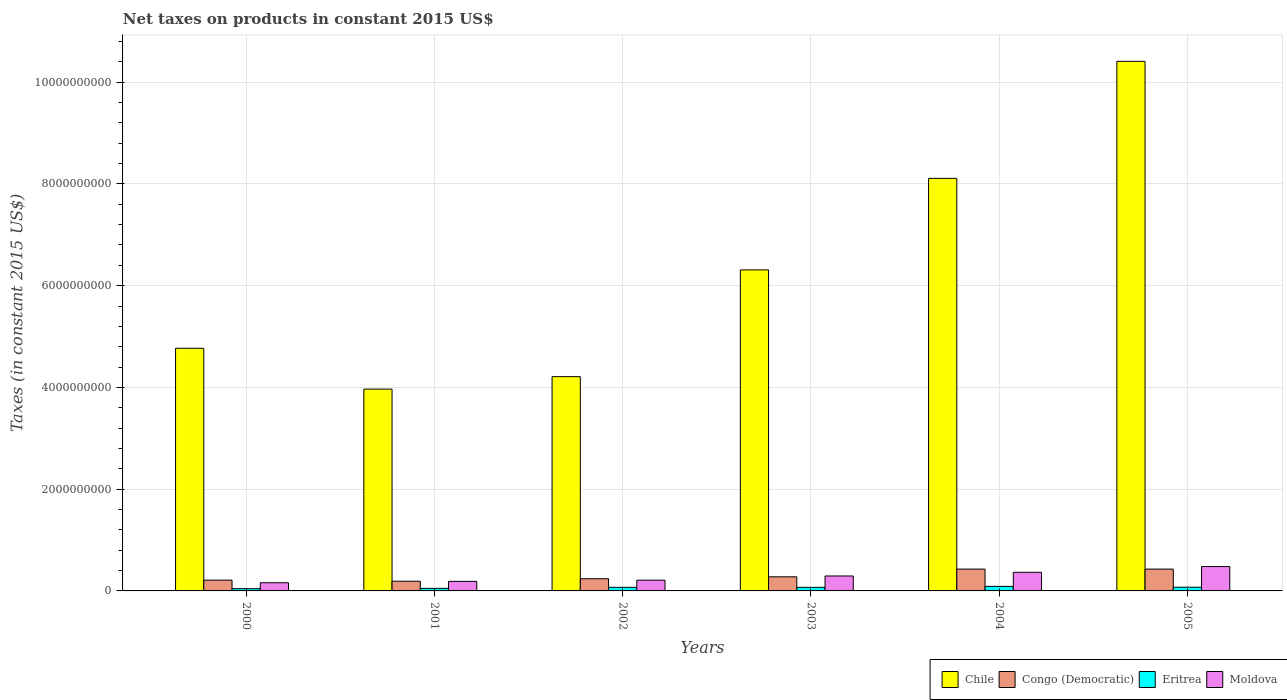How many different coloured bars are there?
Provide a succinct answer. 4. Are the number of bars per tick equal to the number of legend labels?
Offer a very short reply. Yes. Are the number of bars on each tick of the X-axis equal?
Ensure brevity in your answer.  Yes. What is the label of the 5th group of bars from the left?
Offer a very short reply. 2004. What is the net taxes on products in Chile in 2002?
Your response must be concise. 4.21e+09. Across all years, what is the maximum net taxes on products in Chile?
Offer a terse response. 1.04e+1. Across all years, what is the minimum net taxes on products in Chile?
Provide a succinct answer. 3.97e+09. In which year was the net taxes on products in Chile minimum?
Your answer should be very brief. 2001. What is the total net taxes on products in Eritrea in the graph?
Your response must be concise. 3.98e+08. What is the difference between the net taxes on products in Congo (Democratic) in 2003 and that in 2005?
Keep it short and to the point. -1.52e+08. What is the difference between the net taxes on products in Chile in 2000 and the net taxes on products in Congo (Democratic) in 2001?
Ensure brevity in your answer.  4.58e+09. What is the average net taxes on products in Chile per year?
Offer a very short reply. 6.30e+09. In the year 2004, what is the difference between the net taxes on products in Chile and net taxes on products in Congo (Democratic)?
Give a very brief answer. 7.68e+09. In how many years, is the net taxes on products in Moldova greater than 6400000000 US$?
Your answer should be compact. 0. What is the ratio of the net taxes on products in Chile in 2000 to that in 2001?
Offer a very short reply. 1.2. Is the net taxes on products in Congo (Democratic) in 2003 less than that in 2005?
Provide a short and direct response. Yes. Is the difference between the net taxes on products in Chile in 2003 and 2005 greater than the difference between the net taxes on products in Congo (Democratic) in 2003 and 2005?
Make the answer very short. No. What is the difference between the highest and the second highest net taxes on products in Chile?
Provide a succinct answer. 2.30e+09. What is the difference between the highest and the lowest net taxes on products in Moldova?
Provide a succinct answer. 3.18e+08. What does the 4th bar from the left in 2002 represents?
Your answer should be compact. Moldova. What does the 3rd bar from the right in 2003 represents?
Ensure brevity in your answer.  Congo (Democratic). Are all the bars in the graph horizontal?
Offer a terse response. No. How many years are there in the graph?
Your response must be concise. 6. What is the difference between two consecutive major ticks on the Y-axis?
Offer a very short reply. 2.00e+09. How many legend labels are there?
Your answer should be very brief. 4. What is the title of the graph?
Keep it short and to the point. Net taxes on products in constant 2015 US$. What is the label or title of the X-axis?
Offer a terse response. Years. What is the label or title of the Y-axis?
Provide a short and direct response. Taxes (in constant 2015 US$). What is the Taxes (in constant 2015 US$) in Chile in 2000?
Make the answer very short. 4.77e+09. What is the Taxes (in constant 2015 US$) in Congo (Democratic) in 2000?
Make the answer very short. 2.12e+08. What is the Taxes (in constant 2015 US$) in Eritrea in 2000?
Provide a short and direct response. 4.44e+07. What is the Taxes (in constant 2015 US$) in Moldova in 2000?
Provide a succinct answer. 1.61e+08. What is the Taxes (in constant 2015 US$) in Chile in 2001?
Your answer should be compact. 3.97e+09. What is the Taxes (in constant 2015 US$) in Congo (Democratic) in 2001?
Keep it short and to the point. 1.91e+08. What is the Taxes (in constant 2015 US$) of Eritrea in 2001?
Ensure brevity in your answer.  5.02e+07. What is the Taxes (in constant 2015 US$) of Moldova in 2001?
Provide a short and direct response. 1.88e+08. What is the Taxes (in constant 2015 US$) of Chile in 2002?
Offer a terse response. 4.21e+09. What is the Taxes (in constant 2015 US$) of Congo (Democratic) in 2002?
Ensure brevity in your answer.  2.40e+08. What is the Taxes (in constant 2015 US$) of Eritrea in 2002?
Provide a short and direct response. 7.06e+07. What is the Taxes (in constant 2015 US$) of Moldova in 2002?
Your answer should be very brief. 2.11e+08. What is the Taxes (in constant 2015 US$) in Chile in 2003?
Your response must be concise. 6.31e+09. What is the Taxes (in constant 2015 US$) in Congo (Democratic) in 2003?
Offer a terse response. 2.77e+08. What is the Taxes (in constant 2015 US$) in Eritrea in 2003?
Provide a short and direct response. 7.06e+07. What is the Taxes (in constant 2015 US$) of Moldova in 2003?
Make the answer very short. 2.94e+08. What is the Taxes (in constant 2015 US$) of Chile in 2004?
Your answer should be compact. 8.11e+09. What is the Taxes (in constant 2015 US$) of Congo (Democratic) in 2004?
Keep it short and to the point. 4.29e+08. What is the Taxes (in constant 2015 US$) of Eritrea in 2004?
Provide a short and direct response. 8.94e+07. What is the Taxes (in constant 2015 US$) in Moldova in 2004?
Provide a short and direct response. 3.66e+08. What is the Taxes (in constant 2015 US$) of Chile in 2005?
Give a very brief answer. 1.04e+1. What is the Taxes (in constant 2015 US$) of Congo (Democratic) in 2005?
Your response must be concise. 4.29e+08. What is the Taxes (in constant 2015 US$) in Eritrea in 2005?
Your answer should be compact. 7.30e+07. What is the Taxes (in constant 2015 US$) in Moldova in 2005?
Your answer should be compact. 4.79e+08. Across all years, what is the maximum Taxes (in constant 2015 US$) in Chile?
Keep it short and to the point. 1.04e+1. Across all years, what is the maximum Taxes (in constant 2015 US$) of Congo (Democratic)?
Your answer should be very brief. 4.29e+08. Across all years, what is the maximum Taxes (in constant 2015 US$) in Eritrea?
Provide a succinct answer. 8.94e+07. Across all years, what is the maximum Taxes (in constant 2015 US$) in Moldova?
Make the answer very short. 4.79e+08. Across all years, what is the minimum Taxes (in constant 2015 US$) of Chile?
Provide a short and direct response. 3.97e+09. Across all years, what is the minimum Taxes (in constant 2015 US$) of Congo (Democratic)?
Offer a very short reply. 1.91e+08. Across all years, what is the minimum Taxes (in constant 2015 US$) in Eritrea?
Ensure brevity in your answer.  4.44e+07. Across all years, what is the minimum Taxes (in constant 2015 US$) in Moldova?
Offer a terse response. 1.61e+08. What is the total Taxes (in constant 2015 US$) in Chile in the graph?
Offer a terse response. 3.78e+1. What is the total Taxes (in constant 2015 US$) in Congo (Democratic) in the graph?
Offer a very short reply. 1.78e+09. What is the total Taxes (in constant 2015 US$) of Eritrea in the graph?
Keep it short and to the point. 3.98e+08. What is the total Taxes (in constant 2015 US$) in Moldova in the graph?
Offer a terse response. 1.70e+09. What is the difference between the Taxes (in constant 2015 US$) of Chile in 2000 and that in 2001?
Make the answer very short. 8.04e+08. What is the difference between the Taxes (in constant 2015 US$) of Congo (Democratic) in 2000 and that in 2001?
Provide a short and direct response. 2.06e+07. What is the difference between the Taxes (in constant 2015 US$) of Eritrea in 2000 and that in 2001?
Your answer should be compact. -5.80e+06. What is the difference between the Taxes (in constant 2015 US$) of Moldova in 2000 and that in 2001?
Give a very brief answer. -2.71e+07. What is the difference between the Taxes (in constant 2015 US$) of Chile in 2000 and that in 2002?
Your response must be concise. 5.58e+08. What is the difference between the Taxes (in constant 2015 US$) in Congo (Democratic) in 2000 and that in 2002?
Make the answer very short. -2.81e+07. What is the difference between the Taxes (in constant 2015 US$) of Eritrea in 2000 and that in 2002?
Your answer should be compact. -2.62e+07. What is the difference between the Taxes (in constant 2015 US$) in Moldova in 2000 and that in 2002?
Your answer should be compact. -5.05e+07. What is the difference between the Taxes (in constant 2015 US$) in Chile in 2000 and that in 2003?
Make the answer very short. -1.54e+09. What is the difference between the Taxes (in constant 2015 US$) in Congo (Democratic) in 2000 and that in 2003?
Your answer should be compact. -6.54e+07. What is the difference between the Taxes (in constant 2015 US$) in Eritrea in 2000 and that in 2003?
Offer a terse response. -2.62e+07. What is the difference between the Taxes (in constant 2015 US$) of Moldova in 2000 and that in 2003?
Provide a short and direct response. -1.33e+08. What is the difference between the Taxes (in constant 2015 US$) of Chile in 2000 and that in 2004?
Provide a succinct answer. -3.34e+09. What is the difference between the Taxes (in constant 2015 US$) of Congo (Democratic) in 2000 and that in 2004?
Your response must be concise. -2.17e+08. What is the difference between the Taxes (in constant 2015 US$) in Eritrea in 2000 and that in 2004?
Give a very brief answer. -4.50e+07. What is the difference between the Taxes (in constant 2015 US$) of Moldova in 2000 and that in 2004?
Give a very brief answer. -2.06e+08. What is the difference between the Taxes (in constant 2015 US$) of Chile in 2000 and that in 2005?
Offer a terse response. -5.64e+09. What is the difference between the Taxes (in constant 2015 US$) of Congo (Democratic) in 2000 and that in 2005?
Provide a succinct answer. -2.17e+08. What is the difference between the Taxes (in constant 2015 US$) of Eritrea in 2000 and that in 2005?
Ensure brevity in your answer.  -2.86e+07. What is the difference between the Taxes (in constant 2015 US$) in Moldova in 2000 and that in 2005?
Provide a short and direct response. -3.18e+08. What is the difference between the Taxes (in constant 2015 US$) of Chile in 2001 and that in 2002?
Offer a terse response. -2.45e+08. What is the difference between the Taxes (in constant 2015 US$) of Congo (Democratic) in 2001 and that in 2002?
Provide a short and direct response. -4.87e+07. What is the difference between the Taxes (in constant 2015 US$) in Eritrea in 2001 and that in 2002?
Give a very brief answer. -2.04e+07. What is the difference between the Taxes (in constant 2015 US$) in Moldova in 2001 and that in 2002?
Offer a terse response. -2.35e+07. What is the difference between the Taxes (in constant 2015 US$) of Chile in 2001 and that in 2003?
Your answer should be very brief. -2.34e+09. What is the difference between the Taxes (in constant 2015 US$) of Congo (Democratic) in 2001 and that in 2003?
Offer a very short reply. -8.60e+07. What is the difference between the Taxes (in constant 2015 US$) in Eritrea in 2001 and that in 2003?
Offer a terse response. -2.04e+07. What is the difference between the Taxes (in constant 2015 US$) in Moldova in 2001 and that in 2003?
Your response must be concise. -1.06e+08. What is the difference between the Taxes (in constant 2015 US$) in Chile in 2001 and that in 2004?
Your answer should be compact. -4.14e+09. What is the difference between the Taxes (in constant 2015 US$) in Congo (Democratic) in 2001 and that in 2004?
Your response must be concise. -2.38e+08. What is the difference between the Taxes (in constant 2015 US$) of Eritrea in 2001 and that in 2004?
Offer a terse response. -3.92e+07. What is the difference between the Taxes (in constant 2015 US$) of Moldova in 2001 and that in 2004?
Provide a succinct answer. -1.78e+08. What is the difference between the Taxes (in constant 2015 US$) of Chile in 2001 and that in 2005?
Offer a very short reply. -6.44e+09. What is the difference between the Taxes (in constant 2015 US$) in Congo (Democratic) in 2001 and that in 2005?
Give a very brief answer. -2.38e+08. What is the difference between the Taxes (in constant 2015 US$) of Eritrea in 2001 and that in 2005?
Offer a terse response. -2.28e+07. What is the difference between the Taxes (in constant 2015 US$) in Moldova in 2001 and that in 2005?
Provide a short and direct response. -2.91e+08. What is the difference between the Taxes (in constant 2015 US$) of Chile in 2002 and that in 2003?
Offer a terse response. -2.10e+09. What is the difference between the Taxes (in constant 2015 US$) in Congo (Democratic) in 2002 and that in 2003?
Offer a very short reply. -3.73e+07. What is the difference between the Taxes (in constant 2015 US$) in Eritrea in 2002 and that in 2003?
Offer a very short reply. -1.22e+04. What is the difference between the Taxes (in constant 2015 US$) of Moldova in 2002 and that in 2003?
Make the answer very short. -8.26e+07. What is the difference between the Taxes (in constant 2015 US$) in Chile in 2002 and that in 2004?
Provide a short and direct response. -3.90e+09. What is the difference between the Taxes (in constant 2015 US$) of Congo (Democratic) in 2002 and that in 2004?
Provide a short and direct response. -1.89e+08. What is the difference between the Taxes (in constant 2015 US$) in Eritrea in 2002 and that in 2004?
Ensure brevity in your answer.  -1.88e+07. What is the difference between the Taxes (in constant 2015 US$) in Moldova in 2002 and that in 2004?
Make the answer very short. -1.55e+08. What is the difference between the Taxes (in constant 2015 US$) of Chile in 2002 and that in 2005?
Your answer should be compact. -6.20e+09. What is the difference between the Taxes (in constant 2015 US$) in Congo (Democratic) in 2002 and that in 2005?
Provide a short and direct response. -1.89e+08. What is the difference between the Taxes (in constant 2015 US$) of Eritrea in 2002 and that in 2005?
Your response must be concise. -2.41e+06. What is the difference between the Taxes (in constant 2015 US$) in Moldova in 2002 and that in 2005?
Your answer should be compact. -2.68e+08. What is the difference between the Taxes (in constant 2015 US$) of Chile in 2003 and that in 2004?
Keep it short and to the point. -1.80e+09. What is the difference between the Taxes (in constant 2015 US$) of Congo (Democratic) in 2003 and that in 2004?
Your answer should be compact. -1.52e+08. What is the difference between the Taxes (in constant 2015 US$) of Eritrea in 2003 and that in 2004?
Give a very brief answer. -1.88e+07. What is the difference between the Taxes (in constant 2015 US$) in Moldova in 2003 and that in 2004?
Ensure brevity in your answer.  -7.24e+07. What is the difference between the Taxes (in constant 2015 US$) in Chile in 2003 and that in 2005?
Give a very brief answer. -4.10e+09. What is the difference between the Taxes (in constant 2015 US$) in Congo (Democratic) in 2003 and that in 2005?
Keep it short and to the point. -1.52e+08. What is the difference between the Taxes (in constant 2015 US$) in Eritrea in 2003 and that in 2005?
Provide a succinct answer. -2.40e+06. What is the difference between the Taxes (in constant 2015 US$) of Moldova in 2003 and that in 2005?
Keep it short and to the point. -1.85e+08. What is the difference between the Taxes (in constant 2015 US$) in Chile in 2004 and that in 2005?
Give a very brief answer. -2.30e+09. What is the difference between the Taxes (in constant 2015 US$) in Congo (Democratic) in 2004 and that in 2005?
Your answer should be compact. 3.69e+04. What is the difference between the Taxes (in constant 2015 US$) in Eritrea in 2004 and that in 2005?
Keep it short and to the point. 1.64e+07. What is the difference between the Taxes (in constant 2015 US$) in Moldova in 2004 and that in 2005?
Provide a succinct answer. -1.13e+08. What is the difference between the Taxes (in constant 2015 US$) of Chile in 2000 and the Taxes (in constant 2015 US$) of Congo (Democratic) in 2001?
Your answer should be compact. 4.58e+09. What is the difference between the Taxes (in constant 2015 US$) of Chile in 2000 and the Taxes (in constant 2015 US$) of Eritrea in 2001?
Provide a succinct answer. 4.72e+09. What is the difference between the Taxes (in constant 2015 US$) in Chile in 2000 and the Taxes (in constant 2015 US$) in Moldova in 2001?
Ensure brevity in your answer.  4.58e+09. What is the difference between the Taxes (in constant 2015 US$) in Congo (Democratic) in 2000 and the Taxes (in constant 2015 US$) in Eritrea in 2001?
Give a very brief answer. 1.61e+08. What is the difference between the Taxes (in constant 2015 US$) of Congo (Democratic) in 2000 and the Taxes (in constant 2015 US$) of Moldova in 2001?
Make the answer very short. 2.39e+07. What is the difference between the Taxes (in constant 2015 US$) in Eritrea in 2000 and the Taxes (in constant 2015 US$) in Moldova in 2001?
Provide a succinct answer. -1.43e+08. What is the difference between the Taxes (in constant 2015 US$) of Chile in 2000 and the Taxes (in constant 2015 US$) of Congo (Democratic) in 2002?
Keep it short and to the point. 4.53e+09. What is the difference between the Taxes (in constant 2015 US$) of Chile in 2000 and the Taxes (in constant 2015 US$) of Eritrea in 2002?
Your answer should be compact. 4.70e+09. What is the difference between the Taxes (in constant 2015 US$) of Chile in 2000 and the Taxes (in constant 2015 US$) of Moldova in 2002?
Make the answer very short. 4.56e+09. What is the difference between the Taxes (in constant 2015 US$) of Congo (Democratic) in 2000 and the Taxes (in constant 2015 US$) of Eritrea in 2002?
Give a very brief answer. 1.41e+08. What is the difference between the Taxes (in constant 2015 US$) of Congo (Democratic) in 2000 and the Taxes (in constant 2015 US$) of Moldova in 2002?
Your answer should be very brief. 3.98e+05. What is the difference between the Taxes (in constant 2015 US$) of Eritrea in 2000 and the Taxes (in constant 2015 US$) of Moldova in 2002?
Your answer should be compact. -1.67e+08. What is the difference between the Taxes (in constant 2015 US$) of Chile in 2000 and the Taxes (in constant 2015 US$) of Congo (Democratic) in 2003?
Your answer should be very brief. 4.49e+09. What is the difference between the Taxes (in constant 2015 US$) of Chile in 2000 and the Taxes (in constant 2015 US$) of Eritrea in 2003?
Provide a succinct answer. 4.70e+09. What is the difference between the Taxes (in constant 2015 US$) in Chile in 2000 and the Taxes (in constant 2015 US$) in Moldova in 2003?
Offer a very short reply. 4.48e+09. What is the difference between the Taxes (in constant 2015 US$) in Congo (Democratic) in 2000 and the Taxes (in constant 2015 US$) in Eritrea in 2003?
Offer a very short reply. 1.41e+08. What is the difference between the Taxes (in constant 2015 US$) in Congo (Democratic) in 2000 and the Taxes (in constant 2015 US$) in Moldova in 2003?
Your answer should be very brief. -8.22e+07. What is the difference between the Taxes (in constant 2015 US$) in Eritrea in 2000 and the Taxes (in constant 2015 US$) in Moldova in 2003?
Provide a short and direct response. -2.49e+08. What is the difference between the Taxes (in constant 2015 US$) of Chile in 2000 and the Taxes (in constant 2015 US$) of Congo (Democratic) in 2004?
Make the answer very short. 4.34e+09. What is the difference between the Taxes (in constant 2015 US$) in Chile in 2000 and the Taxes (in constant 2015 US$) in Eritrea in 2004?
Offer a very short reply. 4.68e+09. What is the difference between the Taxes (in constant 2015 US$) of Chile in 2000 and the Taxes (in constant 2015 US$) of Moldova in 2004?
Provide a short and direct response. 4.40e+09. What is the difference between the Taxes (in constant 2015 US$) in Congo (Democratic) in 2000 and the Taxes (in constant 2015 US$) in Eritrea in 2004?
Provide a succinct answer. 1.22e+08. What is the difference between the Taxes (in constant 2015 US$) of Congo (Democratic) in 2000 and the Taxes (in constant 2015 US$) of Moldova in 2004?
Your answer should be very brief. -1.55e+08. What is the difference between the Taxes (in constant 2015 US$) of Eritrea in 2000 and the Taxes (in constant 2015 US$) of Moldova in 2004?
Provide a short and direct response. -3.22e+08. What is the difference between the Taxes (in constant 2015 US$) of Chile in 2000 and the Taxes (in constant 2015 US$) of Congo (Democratic) in 2005?
Your answer should be very brief. 4.34e+09. What is the difference between the Taxes (in constant 2015 US$) in Chile in 2000 and the Taxes (in constant 2015 US$) in Eritrea in 2005?
Your answer should be very brief. 4.70e+09. What is the difference between the Taxes (in constant 2015 US$) in Chile in 2000 and the Taxes (in constant 2015 US$) in Moldova in 2005?
Your answer should be compact. 4.29e+09. What is the difference between the Taxes (in constant 2015 US$) of Congo (Democratic) in 2000 and the Taxes (in constant 2015 US$) of Eritrea in 2005?
Your answer should be very brief. 1.39e+08. What is the difference between the Taxes (in constant 2015 US$) of Congo (Democratic) in 2000 and the Taxes (in constant 2015 US$) of Moldova in 2005?
Your answer should be compact. -2.67e+08. What is the difference between the Taxes (in constant 2015 US$) in Eritrea in 2000 and the Taxes (in constant 2015 US$) in Moldova in 2005?
Give a very brief answer. -4.35e+08. What is the difference between the Taxes (in constant 2015 US$) of Chile in 2001 and the Taxes (in constant 2015 US$) of Congo (Democratic) in 2002?
Offer a terse response. 3.73e+09. What is the difference between the Taxes (in constant 2015 US$) of Chile in 2001 and the Taxes (in constant 2015 US$) of Eritrea in 2002?
Provide a succinct answer. 3.90e+09. What is the difference between the Taxes (in constant 2015 US$) of Chile in 2001 and the Taxes (in constant 2015 US$) of Moldova in 2002?
Offer a terse response. 3.75e+09. What is the difference between the Taxes (in constant 2015 US$) in Congo (Democratic) in 2001 and the Taxes (in constant 2015 US$) in Eritrea in 2002?
Provide a short and direct response. 1.20e+08. What is the difference between the Taxes (in constant 2015 US$) of Congo (Democratic) in 2001 and the Taxes (in constant 2015 US$) of Moldova in 2002?
Provide a succinct answer. -2.02e+07. What is the difference between the Taxes (in constant 2015 US$) in Eritrea in 2001 and the Taxes (in constant 2015 US$) in Moldova in 2002?
Your answer should be very brief. -1.61e+08. What is the difference between the Taxes (in constant 2015 US$) of Chile in 2001 and the Taxes (in constant 2015 US$) of Congo (Democratic) in 2003?
Your response must be concise. 3.69e+09. What is the difference between the Taxes (in constant 2015 US$) of Chile in 2001 and the Taxes (in constant 2015 US$) of Eritrea in 2003?
Offer a terse response. 3.90e+09. What is the difference between the Taxes (in constant 2015 US$) of Chile in 2001 and the Taxes (in constant 2015 US$) of Moldova in 2003?
Offer a very short reply. 3.67e+09. What is the difference between the Taxes (in constant 2015 US$) in Congo (Democratic) in 2001 and the Taxes (in constant 2015 US$) in Eritrea in 2003?
Offer a very short reply. 1.20e+08. What is the difference between the Taxes (in constant 2015 US$) of Congo (Democratic) in 2001 and the Taxes (in constant 2015 US$) of Moldova in 2003?
Keep it short and to the point. -1.03e+08. What is the difference between the Taxes (in constant 2015 US$) in Eritrea in 2001 and the Taxes (in constant 2015 US$) in Moldova in 2003?
Offer a terse response. -2.44e+08. What is the difference between the Taxes (in constant 2015 US$) of Chile in 2001 and the Taxes (in constant 2015 US$) of Congo (Democratic) in 2004?
Your answer should be very brief. 3.54e+09. What is the difference between the Taxes (in constant 2015 US$) of Chile in 2001 and the Taxes (in constant 2015 US$) of Eritrea in 2004?
Provide a succinct answer. 3.88e+09. What is the difference between the Taxes (in constant 2015 US$) in Chile in 2001 and the Taxes (in constant 2015 US$) in Moldova in 2004?
Ensure brevity in your answer.  3.60e+09. What is the difference between the Taxes (in constant 2015 US$) in Congo (Democratic) in 2001 and the Taxes (in constant 2015 US$) in Eritrea in 2004?
Keep it short and to the point. 1.02e+08. What is the difference between the Taxes (in constant 2015 US$) in Congo (Democratic) in 2001 and the Taxes (in constant 2015 US$) in Moldova in 2004?
Your answer should be compact. -1.75e+08. What is the difference between the Taxes (in constant 2015 US$) in Eritrea in 2001 and the Taxes (in constant 2015 US$) in Moldova in 2004?
Your answer should be very brief. -3.16e+08. What is the difference between the Taxes (in constant 2015 US$) in Chile in 2001 and the Taxes (in constant 2015 US$) in Congo (Democratic) in 2005?
Your answer should be very brief. 3.54e+09. What is the difference between the Taxes (in constant 2015 US$) in Chile in 2001 and the Taxes (in constant 2015 US$) in Eritrea in 2005?
Provide a short and direct response. 3.89e+09. What is the difference between the Taxes (in constant 2015 US$) in Chile in 2001 and the Taxes (in constant 2015 US$) in Moldova in 2005?
Your answer should be compact. 3.49e+09. What is the difference between the Taxes (in constant 2015 US$) in Congo (Democratic) in 2001 and the Taxes (in constant 2015 US$) in Eritrea in 2005?
Make the answer very short. 1.18e+08. What is the difference between the Taxes (in constant 2015 US$) of Congo (Democratic) in 2001 and the Taxes (in constant 2015 US$) of Moldova in 2005?
Your response must be concise. -2.88e+08. What is the difference between the Taxes (in constant 2015 US$) in Eritrea in 2001 and the Taxes (in constant 2015 US$) in Moldova in 2005?
Give a very brief answer. -4.29e+08. What is the difference between the Taxes (in constant 2015 US$) of Chile in 2002 and the Taxes (in constant 2015 US$) of Congo (Democratic) in 2003?
Keep it short and to the point. 3.93e+09. What is the difference between the Taxes (in constant 2015 US$) of Chile in 2002 and the Taxes (in constant 2015 US$) of Eritrea in 2003?
Your answer should be very brief. 4.14e+09. What is the difference between the Taxes (in constant 2015 US$) of Chile in 2002 and the Taxes (in constant 2015 US$) of Moldova in 2003?
Offer a very short reply. 3.92e+09. What is the difference between the Taxes (in constant 2015 US$) in Congo (Democratic) in 2002 and the Taxes (in constant 2015 US$) in Eritrea in 2003?
Ensure brevity in your answer.  1.69e+08. What is the difference between the Taxes (in constant 2015 US$) of Congo (Democratic) in 2002 and the Taxes (in constant 2015 US$) of Moldova in 2003?
Provide a short and direct response. -5.41e+07. What is the difference between the Taxes (in constant 2015 US$) of Eritrea in 2002 and the Taxes (in constant 2015 US$) of Moldova in 2003?
Provide a succinct answer. -2.23e+08. What is the difference between the Taxes (in constant 2015 US$) in Chile in 2002 and the Taxes (in constant 2015 US$) in Congo (Democratic) in 2004?
Make the answer very short. 3.78e+09. What is the difference between the Taxes (in constant 2015 US$) in Chile in 2002 and the Taxes (in constant 2015 US$) in Eritrea in 2004?
Make the answer very short. 4.12e+09. What is the difference between the Taxes (in constant 2015 US$) in Chile in 2002 and the Taxes (in constant 2015 US$) in Moldova in 2004?
Provide a succinct answer. 3.85e+09. What is the difference between the Taxes (in constant 2015 US$) of Congo (Democratic) in 2002 and the Taxes (in constant 2015 US$) of Eritrea in 2004?
Provide a succinct answer. 1.50e+08. What is the difference between the Taxes (in constant 2015 US$) in Congo (Democratic) in 2002 and the Taxes (in constant 2015 US$) in Moldova in 2004?
Your answer should be compact. -1.26e+08. What is the difference between the Taxes (in constant 2015 US$) of Eritrea in 2002 and the Taxes (in constant 2015 US$) of Moldova in 2004?
Provide a short and direct response. -2.96e+08. What is the difference between the Taxes (in constant 2015 US$) of Chile in 2002 and the Taxes (in constant 2015 US$) of Congo (Democratic) in 2005?
Provide a succinct answer. 3.78e+09. What is the difference between the Taxes (in constant 2015 US$) of Chile in 2002 and the Taxes (in constant 2015 US$) of Eritrea in 2005?
Offer a terse response. 4.14e+09. What is the difference between the Taxes (in constant 2015 US$) in Chile in 2002 and the Taxes (in constant 2015 US$) in Moldova in 2005?
Provide a succinct answer. 3.73e+09. What is the difference between the Taxes (in constant 2015 US$) in Congo (Democratic) in 2002 and the Taxes (in constant 2015 US$) in Eritrea in 2005?
Make the answer very short. 1.67e+08. What is the difference between the Taxes (in constant 2015 US$) in Congo (Democratic) in 2002 and the Taxes (in constant 2015 US$) in Moldova in 2005?
Ensure brevity in your answer.  -2.39e+08. What is the difference between the Taxes (in constant 2015 US$) of Eritrea in 2002 and the Taxes (in constant 2015 US$) of Moldova in 2005?
Make the answer very short. -4.08e+08. What is the difference between the Taxes (in constant 2015 US$) in Chile in 2003 and the Taxes (in constant 2015 US$) in Congo (Democratic) in 2004?
Provide a short and direct response. 5.88e+09. What is the difference between the Taxes (in constant 2015 US$) in Chile in 2003 and the Taxes (in constant 2015 US$) in Eritrea in 2004?
Your response must be concise. 6.22e+09. What is the difference between the Taxes (in constant 2015 US$) of Chile in 2003 and the Taxes (in constant 2015 US$) of Moldova in 2004?
Provide a short and direct response. 5.94e+09. What is the difference between the Taxes (in constant 2015 US$) of Congo (Democratic) in 2003 and the Taxes (in constant 2015 US$) of Eritrea in 2004?
Your answer should be compact. 1.88e+08. What is the difference between the Taxes (in constant 2015 US$) in Congo (Democratic) in 2003 and the Taxes (in constant 2015 US$) in Moldova in 2004?
Provide a short and direct response. -8.92e+07. What is the difference between the Taxes (in constant 2015 US$) in Eritrea in 2003 and the Taxes (in constant 2015 US$) in Moldova in 2004?
Your response must be concise. -2.96e+08. What is the difference between the Taxes (in constant 2015 US$) in Chile in 2003 and the Taxes (in constant 2015 US$) in Congo (Democratic) in 2005?
Make the answer very short. 5.88e+09. What is the difference between the Taxes (in constant 2015 US$) of Chile in 2003 and the Taxes (in constant 2015 US$) of Eritrea in 2005?
Offer a very short reply. 6.24e+09. What is the difference between the Taxes (in constant 2015 US$) of Chile in 2003 and the Taxes (in constant 2015 US$) of Moldova in 2005?
Give a very brief answer. 5.83e+09. What is the difference between the Taxes (in constant 2015 US$) in Congo (Democratic) in 2003 and the Taxes (in constant 2015 US$) in Eritrea in 2005?
Offer a terse response. 2.04e+08. What is the difference between the Taxes (in constant 2015 US$) in Congo (Democratic) in 2003 and the Taxes (in constant 2015 US$) in Moldova in 2005?
Your answer should be compact. -2.02e+08. What is the difference between the Taxes (in constant 2015 US$) in Eritrea in 2003 and the Taxes (in constant 2015 US$) in Moldova in 2005?
Give a very brief answer. -4.08e+08. What is the difference between the Taxes (in constant 2015 US$) of Chile in 2004 and the Taxes (in constant 2015 US$) of Congo (Democratic) in 2005?
Make the answer very short. 7.68e+09. What is the difference between the Taxes (in constant 2015 US$) in Chile in 2004 and the Taxes (in constant 2015 US$) in Eritrea in 2005?
Offer a terse response. 8.04e+09. What is the difference between the Taxes (in constant 2015 US$) in Chile in 2004 and the Taxes (in constant 2015 US$) in Moldova in 2005?
Your answer should be very brief. 7.63e+09. What is the difference between the Taxes (in constant 2015 US$) of Congo (Democratic) in 2004 and the Taxes (in constant 2015 US$) of Eritrea in 2005?
Provide a succinct answer. 3.56e+08. What is the difference between the Taxes (in constant 2015 US$) of Congo (Democratic) in 2004 and the Taxes (in constant 2015 US$) of Moldova in 2005?
Your response must be concise. -5.02e+07. What is the difference between the Taxes (in constant 2015 US$) of Eritrea in 2004 and the Taxes (in constant 2015 US$) of Moldova in 2005?
Keep it short and to the point. -3.90e+08. What is the average Taxes (in constant 2015 US$) of Chile per year?
Provide a short and direct response. 6.30e+09. What is the average Taxes (in constant 2015 US$) of Congo (Democratic) per year?
Your answer should be compact. 2.96e+08. What is the average Taxes (in constant 2015 US$) of Eritrea per year?
Give a very brief answer. 6.64e+07. What is the average Taxes (in constant 2015 US$) in Moldova per year?
Your response must be concise. 2.83e+08. In the year 2000, what is the difference between the Taxes (in constant 2015 US$) in Chile and Taxes (in constant 2015 US$) in Congo (Democratic)?
Provide a short and direct response. 4.56e+09. In the year 2000, what is the difference between the Taxes (in constant 2015 US$) of Chile and Taxes (in constant 2015 US$) of Eritrea?
Your answer should be compact. 4.73e+09. In the year 2000, what is the difference between the Taxes (in constant 2015 US$) in Chile and Taxes (in constant 2015 US$) in Moldova?
Keep it short and to the point. 4.61e+09. In the year 2000, what is the difference between the Taxes (in constant 2015 US$) in Congo (Democratic) and Taxes (in constant 2015 US$) in Eritrea?
Offer a very short reply. 1.67e+08. In the year 2000, what is the difference between the Taxes (in constant 2015 US$) in Congo (Democratic) and Taxes (in constant 2015 US$) in Moldova?
Your answer should be very brief. 5.09e+07. In the year 2000, what is the difference between the Taxes (in constant 2015 US$) of Eritrea and Taxes (in constant 2015 US$) of Moldova?
Your answer should be very brief. -1.16e+08. In the year 2001, what is the difference between the Taxes (in constant 2015 US$) of Chile and Taxes (in constant 2015 US$) of Congo (Democratic)?
Offer a very short reply. 3.78e+09. In the year 2001, what is the difference between the Taxes (in constant 2015 US$) in Chile and Taxes (in constant 2015 US$) in Eritrea?
Give a very brief answer. 3.92e+09. In the year 2001, what is the difference between the Taxes (in constant 2015 US$) of Chile and Taxes (in constant 2015 US$) of Moldova?
Make the answer very short. 3.78e+09. In the year 2001, what is the difference between the Taxes (in constant 2015 US$) of Congo (Democratic) and Taxes (in constant 2015 US$) of Eritrea?
Provide a short and direct response. 1.41e+08. In the year 2001, what is the difference between the Taxes (in constant 2015 US$) of Congo (Democratic) and Taxes (in constant 2015 US$) of Moldova?
Offer a very short reply. 3.28e+06. In the year 2001, what is the difference between the Taxes (in constant 2015 US$) of Eritrea and Taxes (in constant 2015 US$) of Moldova?
Make the answer very short. -1.37e+08. In the year 2002, what is the difference between the Taxes (in constant 2015 US$) in Chile and Taxes (in constant 2015 US$) in Congo (Democratic)?
Your answer should be very brief. 3.97e+09. In the year 2002, what is the difference between the Taxes (in constant 2015 US$) of Chile and Taxes (in constant 2015 US$) of Eritrea?
Offer a very short reply. 4.14e+09. In the year 2002, what is the difference between the Taxes (in constant 2015 US$) in Chile and Taxes (in constant 2015 US$) in Moldova?
Ensure brevity in your answer.  4.00e+09. In the year 2002, what is the difference between the Taxes (in constant 2015 US$) in Congo (Democratic) and Taxes (in constant 2015 US$) in Eritrea?
Provide a succinct answer. 1.69e+08. In the year 2002, what is the difference between the Taxes (in constant 2015 US$) of Congo (Democratic) and Taxes (in constant 2015 US$) of Moldova?
Make the answer very short. 2.85e+07. In the year 2002, what is the difference between the Taxes (in constant 2015 US$) in Eritrea and Taxes (in constant 2015 US$) in Moldova?
Keep it short and to the point. -1.41e+08. In the year 2003, what is the difference between the Taxes (in constant 2015 US$) in Chile and Taxes (in constant 2015 US$) in Congo (Democratic)?
Ensure brevity in your answer.  6.03e+09. In the year 2003, what is the difference between the Taxes (in constant 2015 US$) in Chile and Taxes (in constant 2015 US$) in Eritrea?
Make the answer very short. 6.24e+09. In the year 2003, what is the difference between the Taxes (in constant 2015 US$) in Chile and Taxes (in constant 2015 US$) in Moldova?
Offer a terse response. 6.02e+09. In the year 2003, what is the difference between the Taxes (in constant 2015 US$) of Congo (Democratic) and Taxes (in constant 2015 US$) of Eritrea?
Your answer should be very brief. 2.06e+08. In the year 2003, what is the difference between the Taxes (in constant 2015 US$) in Congo (Democratic) and Taxes (in constant 2015 US$) in Moldova?
Provide a succinct answer. -1.68e+07. In the year 2003, what is the difference between the Taxes (in constant 2015 US$) in Eritrea and Taxes (in constant 2015 US$) in Moldova?
Keep it short and to the point. -2.23e+08. In the year 2004, what is the difference between the Taxes (in constant 2015 US$) in Chile and Taxes (in constant 2015 US$) in Congo (Democratic)?
Ensure brevity in your answer.  7.68e+09. In the year 2004, what is the difference between the Taxes (in constant 2015 US$) in Chile and Taxes (in constant 2015 US$) in Eritrea?
Provide a short and direct response. 8.02e+09. In the year 2004, what is the difference between the Taxes (in constant 2015 US$) in Chile and Taxes (in constant 2015 US$) in Moldova?
Keep it short and to the point. 7.74e+09. In the year 2004, what is the difference between the Taxes (in constant 2015 US$) of Congo (Democratic) and Taxes (in constant 2015 US$) of Eritrea?
Your answer should be compact. 3.39e+08. In the year 2004, what is the difference between the Taxes (in constant 2015 US$) of Congo (Democratic) and Taxes (in constant 2015 US$) of Moldova?
Your response must be concise. 6.26e+07. In the year 2004, what is the difference between the Taxes (in constant 2015 US$) of Eritrea and Taxes (in constant 2015 US$) of Moldova?
Your response must be concise. -2.77e+08. In the year 2005, what is the difference between the Taxes (in constant 2015 US$) in Chile and Taxes (in constant 2015 US$) in Congo (Democratic)?
Keep it short and to the point. 9.98e+09. In the year 2005, what is the difference between the Taxes (in constant 2015 US$) of Chile and Taxes (in constant 2015 US$) of Eritrea?
Keep it short and to the point. 1.03e+1. In the year 2005, what is the difference between the Taxes (in constant 2015 US$) of Chile and Taxes (in constant 2015 US$) of Moldova?
Provide a short and direct response. 9.93e+09. In the year 2005, what is the difference between the Taxes (in constant 2015 US$) in Congo (Democratic) and Taxes (in constant 2015 US$) in Eritrea?
Offer a very short reply. 3.56e+08. In the year 2005, what is the difference between the Taxes (in constant 2015 US$) in Congo (Democratic) and Taxes (in constant 2015 US$) in Moldova?
Provide a succinct answer. -5.03e+07. In the year 2005, what is the difference between the Taxes (in constant 2015 US$) of Eritrea and Taxes (in constant 2015 US$) of Moldova?
Make the answer very short. -4.06e+08. What is the ratio of the Taxes (in constant 2015 US$) in Chile in 2000 to that in 2001?
Give a very brief answer. 1.2. What is the ratio of the Taxes (in constant 2015 US$) of Congo (Democratic) in 2000 to that in 2001?
Offer a terse response. 1.11. What is the ratio of the Taxes (in constant 2015 US$) of Eritrea in 2000 to that in 2001?
Keep it short and to the point. 0.88. What is the ratio of the Taxes (in constant 2015 US$) in Moldova in 2000 to that in 2001?
Provide a succinct answer. 0.86. What is the ratio of the Taxes (in constant 2015 US$) in Chile in 2000 to that in 2002?
Make the answer very short. 1.13. What is the ratio of the Taxes (in constant 2015 US$) of Congo (Democratic) in 2000 to that in 2002?
Your response must be concise. 0.88. What is the ratio of the Taxes (in constant 2015 US$) of Eritrea in 2000 to that in 2002?
Provide a succinct answer. 0.63. What is the ratio of the Taxes (in constant 2015 US$) in Moldova in 2000 to that in 2002?
Your answer should be very brief. 0.76. What is the ratio of the Taxes (in constant 2015 US$) of Chile in 2000 to that in 2003?
Your answer should be compact. 0.76. What is the ratio of the Taxes (in constant 2015 US$) of Congo (Democratic) in 2000 to that in 2003?
Offer a terse response. 0.76. What is the ratio of the Taxes (in constant 2015 US$) in Eritrea in 2000 to that in 2003?
Keep it short and to the point. 0.63. What is the ratio of the Taxes (in constant 2015 US$) of Moldova in 2000 to that in 2003?
Ensure brevity in your answer.  0.55. What is the ratio of the Taxes (in constant 2015 US$) in Chile in 2000 to that in 2004?
Your response must be concise. 0.59. What is the ratio of the Taxes (in constant 2015 US$) in Congo (Democratic) in 2000 to that in 2004?
Your response must be concise. 0.49. What is the ratio of the Taxes (in constant 2015 US$) of Eritrea in 2000 to that in 2004?
Keep it short and to the point. 0.5. What is the ratio of the Taxes (in constant 2015 US$) in Moldova in 2000 to that in 2004?
Your answer should be very brief. 0.44. What is the ratio of the Taxes (in constant 2015 US$) in Chile in 2000 to that in 2005?
Your answer should be compact. 0.46. What is the ratio of the Taxes (in constant 2015 US$) of Congo (Democratic) in 2000 to that in 2005?
Keep it short and to the point. 0.49. What is the ratio of the Taxes (in constant 2015 US$) in Eritrea in 2000 to that in 2005?
Give a very brief answer. 0.61. What is the ratio of the Taxes (in constant 2015 US$) in Moldova in 2000 to that in 2005?
Your answer should be compact. 0.34. What is the ratio of the Taxes (in constant 2015 US$) in Chile in 2001 to that in 2002?
Make the answer very short. 0.94. What is the ratio of the Taxes (in constant 2015 US$) of Congo (Democratic) in 2001 to that in 2002?
Give a very brief answer. 0.8. What is the ratio of the Taxes (in constant 2015 US$) in Eritrea in 2001 to that in 2002?
Offer a terse response. 0.71. What is the ratio of the Taxes (in constant 2015 US$) in Moldova in 2001 to that in 2002?
Give a very brief answer. 0.89. What is the ratio of the Taxes (in constant 2015 US$) of Chile in 2001 to that in 2003?
Provide a succinct answer. 0.63. What is the ratio of the Taxes (in constant 2015 US$) of Congo (Democratic) in 2001 to that in 2003?
Ensure brevity in your answer.  0.69. What is the ratio of the Taxes (in constant 2015 US$) in Eritrea in 2001 to that in 2003?
Your answer should be compact. 0.71. What is the ratio of the Taxes (in constant 2015 US$) of Moldova in 2001 to that in 2003?
Give a very brief answer. 0.64. What is the ratio of the Taxes (in constant 2015 US$) in Chile in 2001 to that in 2004?
Offer a terse response. 0.49. What is the ratio of the Taxes (in constant 2015 US$) in Congo (Democratic) in 2001 to that in 2004?
Your answer should be compact. 0.45. What is the ratio of the Taxes (in constant 2015 US$) in Eritrea in 2001 to that in 2004?
Your response must be concise. 0.56. What is the ratio of the Taxes (in constant 2015 US$) in Moldova in 2001 to that in 2004?
Your answer should be very brief. 0.51. What is the ratio of the Taxes (in constant 2015 US$) in Chile in 2001 to that in 2005?
Your answer should be compact. 0.38. What is the ratio of the Taxes (in constant 2015 US$) in Congo (Democratic) in 2001 to that in 2005?
Your answer should be compact. 0.45. What is the ratio of the Taxes (in constant 2015 US$) in Eritrea in 2001 to that in 2005?
Ensure brevity in your answer.  0.69. What is the ratio of the Taxes (in constant 2015 US$) in Moldova in 2001 to that in 2005?
Give a very brief answer. 0.39. What is the ratio of the Taxes (in constant 2015 US$) of Chile in 2002 to that in 2003?
Provide a succinct answer. 0.67. What is the ratio of the Taxes (in constant 2015 US$) in Congo (Democratic) in 2002 to that in 2003?
Provide a succinct answer. 0.87. What is the ratio of the Taxes (in constant 2015 US$) of Moldova in 2002 to that in 2003?
Your answer should be very brief. 0.72. What is the ratio of the Taxes (in constant 2015 US$) in Chile in 2002 to that in 2004?
Your answer should be compact. 0.52. What is the ratio of the Taxes (in constant 2015 US$) in Congo (Democratic) in 2002 to that in 2004?
Keep it short and to the point. 0.56. What is the ratio of the Taxes (in constant 2015 US$) in Eritrea in 2002 to that in 2004?
Give a very brief answer. 0.79. What is the ratio of the Taxes (in constant 2015 US$) in Moldova in 2002 to that in 2004?
Provide a short and direct response. 0.58. What is the ratio of the Taxes (in constant 2015 US$) of Chile in 2002 to that in 2005?
Provide a succinct answer. 0.4. What is the ratio of the Taxes (in constant 2015 US$) of Congo (Democratic) in 2002 to that in 2005?
Offer a terse response. 0.56. What is the ratio of the Taxes (in constant 2015 US$) of Eritrea in 2002 to that in 2005?
Give a very brief answer. 0.97. What is the ratio of the Taxes (in constant 2015 US$) of Moldova in 2002 to that in 2005?
Your answer should be compact. 0.44. What is the ratio of the Taxes (in constant 2015 US$) in Chile in 2003 to that in 2004?
Offer a very short reply. 0.78. What is the ratio of the Taxes (in constant 2015 US$) in Congo (Democratic) in 2003 to that in 2004?
Make the answer very short. 0.65. What is the ratio of the Taxes (in constant 2015 US$) in Eritrea in 2003 to that in 2004?
Your answer should be very brief. 0.79. What is the ratio of the Taxes (in constant 2015 US$) in Moldova in 2003 to that in 2004?
Provide a succinct answer. 0.8. What is the ratio of the Taxes (in constant 2015 US$) of Chile in 2003 to that in 2005?
Offer a very short reply. 0.61. What is the ratio of the Taxes (in constant 2015 US$) of Congo (Democratic) in 2003 to that in 2005?
Keep it short and to the point. 0.65. What is the ratio of the Taxes (in constant 2015 US$) in Eritrea in 2003 to that in 2005?
Your answer should be compact. 0.97. What is the ratio of the Taxes (in constant 2015 US$) in Moldova in 2003 to that in 2005?
Keep it short and to the point. 0.61. What is the ratio of the Taxes (in constant 2015 US$) of Chile in 2004 to that in 2005?
Keep it short and to the point. 0.78. What is the ratio of the Taxes (in constant 2015 US$) in Eritrea in 2004 to that in 2005?
Your answer should be compact. 1.22. What is the ratio of the Taxes (in constant 2015 US$) of Moldova in 2004 to that in 2005?
Your response must be concise. 0.76. What is the difference between the highest and the second highest Taxes (in constant 2015 US$) in Chile?
Provide a short and direct response. 2.30e+09. What is the difference between the highest and the second highest Taxes (in constant 2015 US$) of Congo (Democratic)?
Keep it short and to the point. 3.69e+04. What is the difference between the highest and the second highest Taxes (in constant 2015 US$) in Eritrea?
Your answer should be compact. 1.64e+07. What is the difference between the highest and the second highest Taxes (in constant 2015 US$) of Moldova?
Provide a succinct answer. 1.13e+08. What is the difference between the highest and the lowest Taxes (in constant 2015 US$) in Chile?
Ensure brevity in your answer.  6.44e+09. What is the difference between the highest and the lowest Taxes (in constant 2015 US$) of Congo (Democratic)?
Give a very brief answer. 2.38e+08. What is the difference between the highest and the lowest Taxes (in constant 2015 US$) of Eritrea?
Your response must be concise. 4.50e+07. What is the difference between the highest and the lowest Taxes (in constant 2015 US$) in Moldova?
Give a very brief answer. 3.18e+08. 